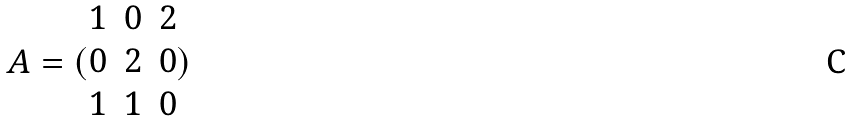<formula> <loc_0><loc_0><loc_500><loc_500>A = ( \begin{matrix} 1 & 0 & 2 \\ 0 & 2 & 0 \\ 1 & 1 & 0 \end{matrix} )</formula> 